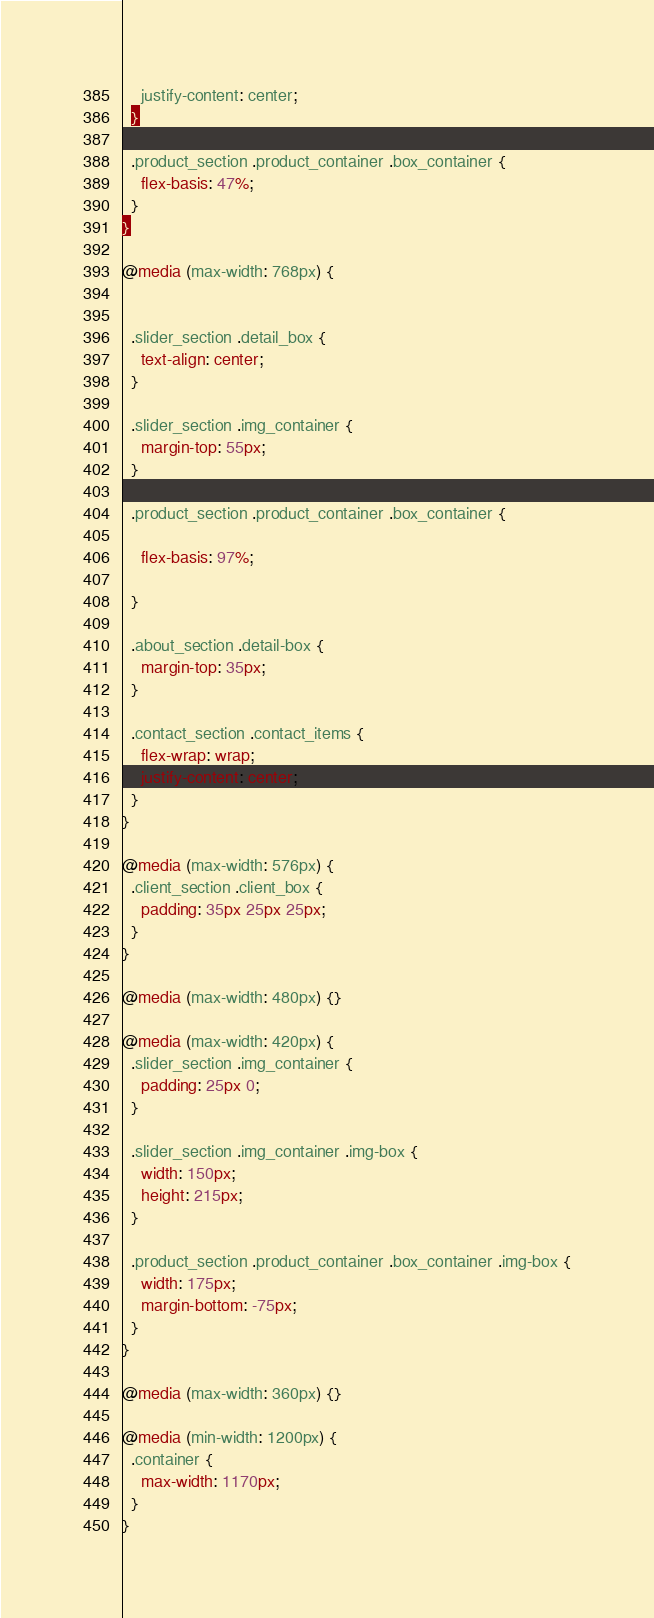Convert code to text. <code><loc_0><loc_0><loc_500><loc_500><_CSS_>    justify-content: center;
  }

  .product_section .product_container .box_container {
    flex-basis: 47%;
  }
}

@media (max-width: 768px) {


  .slider_section .detail_box {
    text-align: center;
  }

  .slider_section .img_container {
    margin-top: 55px;
  }

  .product_section .product_container .box_container {

    flex-basis: 97%;

  }

  .about_section .detail-box {
    margin-top: 35px;
  }

  .contact_section .contact_items {
    flex-wrap: wrap;
    justify-content: center;
  }
}

@media (max-width: 576px) {
  .client_section .client_box {
    padding: 35px 25px 25px;
  }
}

@media (max-width: 480px) {}

@media (max-width: 420px) {
  .slider_section .img_container {
    padding: 25px 0;
  }

  .slider_section .img_container .img-box {
    width: 150px;
    height: 215px;
  }

  .product_section .product_container .box_container .img-box {
    width: 175px;
    margin-bottom: -75px;
  }
}

@media (max-width: 360px) {}

@media (min-width: 1200px) {
  .container {
    max-width: 1170px;
  }
}</code> 